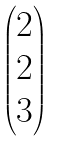Convert formula to latex. <formula><loc_0><loc_0><loc_500><loc_500>\begin{pmatrix} 2 \\ 2 \\ 3 \end{pmatrix}</formula> 